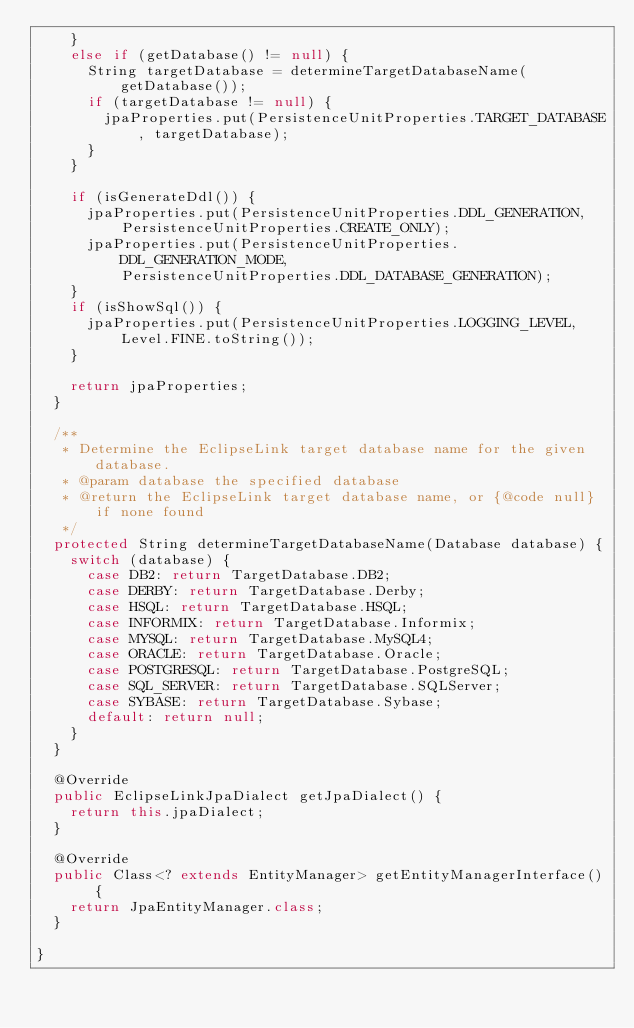Convert code to text. <code><loc_0><loc_0><loc_500><loc_500><_Java_>		}
		else if (getDatabase() != null) {
			String targetDatabase = determineTargetDatabaseName(getDatabase());
			if (targetDatabase != null) {
				jpaProperties.put(PersistenceUnitProperties.TARGET_DATABASE, targetDatabase);
			}
		}

		if (isGenerateDdl()) {
			jpaProperties.put(PersistenceUnitProperties.DDL_GENERATION,
					PersistenceUnitProperties.CREATE_ONLY);
			jpaProperties.put(PersistenceUnitProperties.DDL_GENERATION_MODE,
					PersistenceUnitProperties.DDL_DATABASE_GENERATION);
		}
		if (isShowSql()) {
			jpaProperties.put(PersistenceUnitProperties.LOGGING_LEVEL, Level.FINE.toString());
		}

		return jpaProperties;
	}

	/**
	 * Determine the EclipseLink target database name for the given database.
	 * @param database the specified database
	 * @return the EclipseLink target database name, or {@code null} if none found
	 */
	protected String determineTargetDatabaseName(Database database) {
		switch (database) {
			case DB2: return TargetDatabase.DB2;
			case DERBY: return TargetDatabase.Derby;
			case HSQL: return TargetDatabase.HSQL;
			case INFORMIX: return TargetDatabase.Informix;
			case MYSQL: return TargetDatabase.MySQL4;
			case ORACLE: return TargetDatabase.Oracle;
			case POSTGRESQL: return TargetDatabase.PostgreSQL;
			case SQL_SERVER: return TargetDatabase.SQLServer;
			case SYBASE: return TargetDatabase.Sybase;
			default: return null;
		}
	}

	@Override
	public EclipseLinkJpaDialect getJpaDialect() {
		return this.jpaDialect;
	}

	@Override
	public Class<? extends EntityManager> getEntityManagerInterface() {
		return JpaEntityManager.class;
	}

}
</code> 